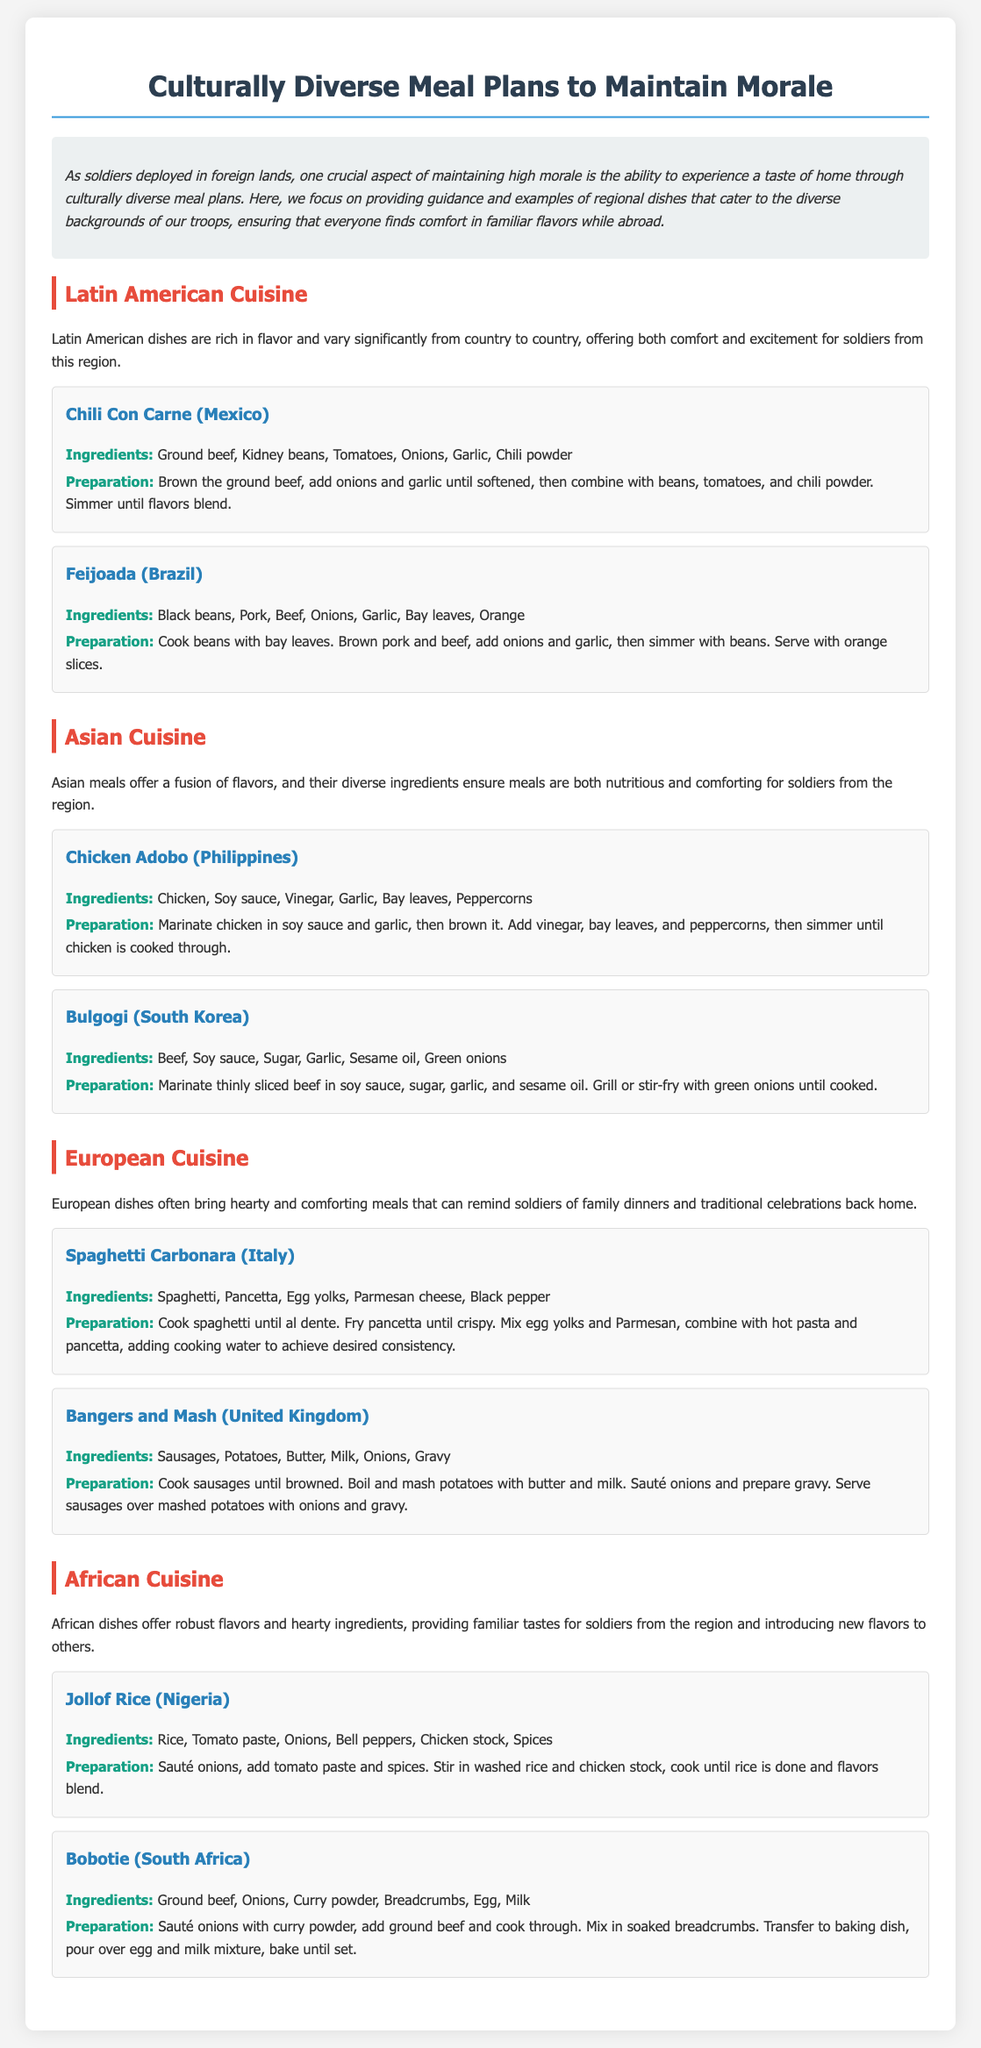What is the title of the document? The title is clearly stated at the beginning of the document, which is "Culturally Diverse Meal Plans to Maintain Morale."
Answer: Culturally Diverse Meal Plans to Maintain Morale How many cuisines are featured in the document? The document includes sections on four different cuisines: Latin American, Asian, European, and African.
Answer: Four What dish is used as an example from Mexico? The dish is specified in the Latin American section as "Chili Con Carne."
Answer: Chili Con Carne Which country is associated with the dish "Bulgogi"? The dish "Bulgogi" is mentioned under the Asian cuisine section, specifically linked to South Korea.
Answer: South Korea What is a common ingredient in the European dishes mentioned? The European section highlights that both dishes, Spaghetti Carbonara and Bangers and Mash, utilize potatoes.
Answer: Potatoes Which dish from Nigeria is listed? The document provides "Jollof Rice" as the Nigerian dish featured in the African cuisine section.
Answer: Jollof Rice How is the chicken prepared in Chicken Adobo? The recipe mentions marinating the chicken in soy sauce and garlic before browning it.
Answer: Marinated What are two ingredients required for the Brazilian dish Feijoada? The ingredients mentioned for Feijoada include black beans and pork.
Answer: Black beans and pork What is the primary cooking method for Bangers and Mash sausages? The document states that sausages are cooked until browned, indicating frying as the method.
Answer: Fried 